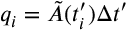Convert formula to latex. <formula><loc_0><loc_0><loc_500><loc_500>q _ { i } = \tilde { A } ( t _ { i } ^ { \prime } ) \Delta t ^ { \prime }</formula> 